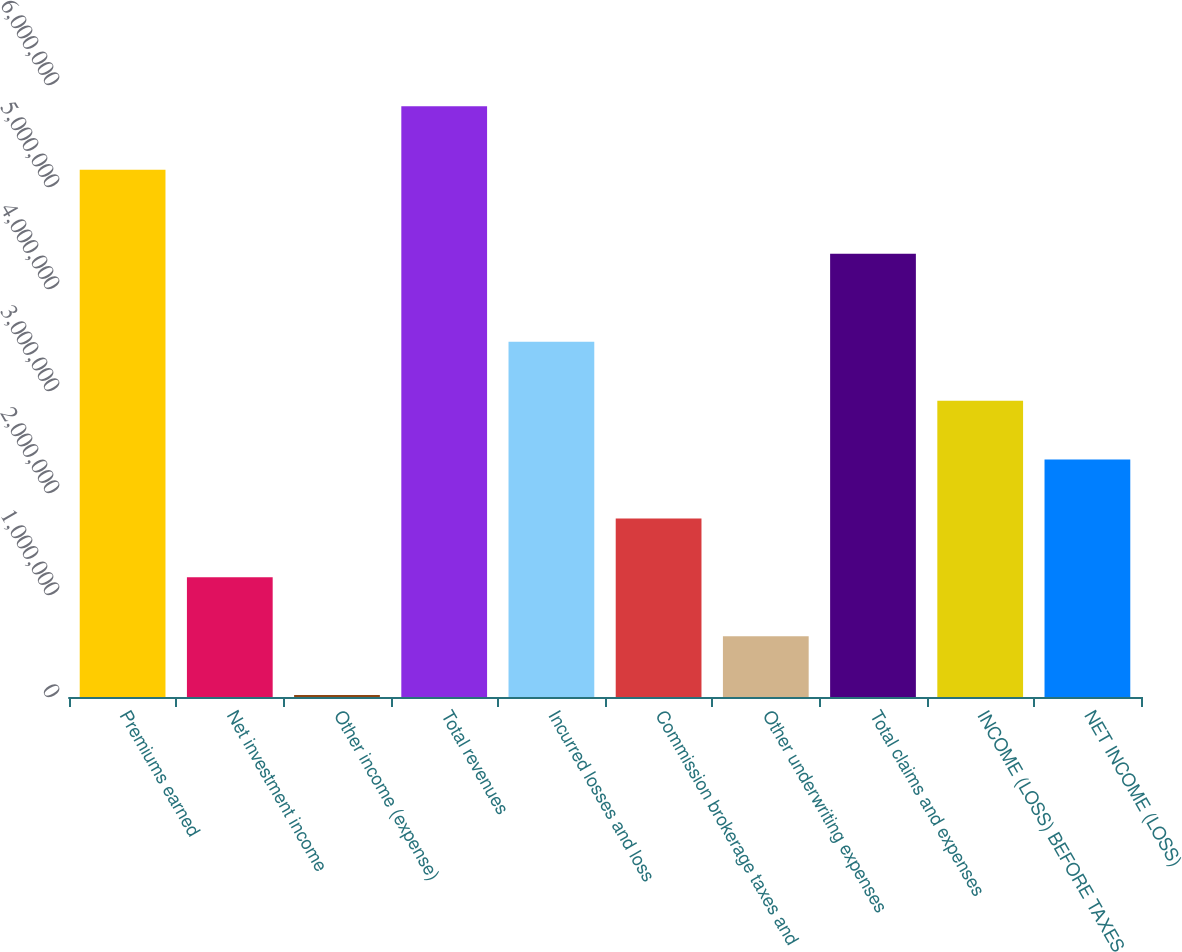Convert chart to OTSL. <chart><loc_0><loc_0><loc_500><loc_500><bar_chart><fcel>Premiums earned<fcel>Net investment income<fcel>Other income (expense)<fcel>Total revenues<fcel>Incurred losses and loss<fcel>Commission brokerage taxes and<fcel>Other underwriting expenses<fcel>Total claims and expenses<fcel>INCOME (LOSS) BEFORE TAXES<fcel>NET INCOME (LOSS)<nl><fcel>5.16914e+06<fcel>1.17287e+06<fcel>18437<fcel>5.79059e+06<fcel>3.48173e+06<fcel>1.75008e+06<fcel>595652<fcel>4.34447e+06<fcel>2.90451e+06<fcel>2.3273e+06<nl></chart> 